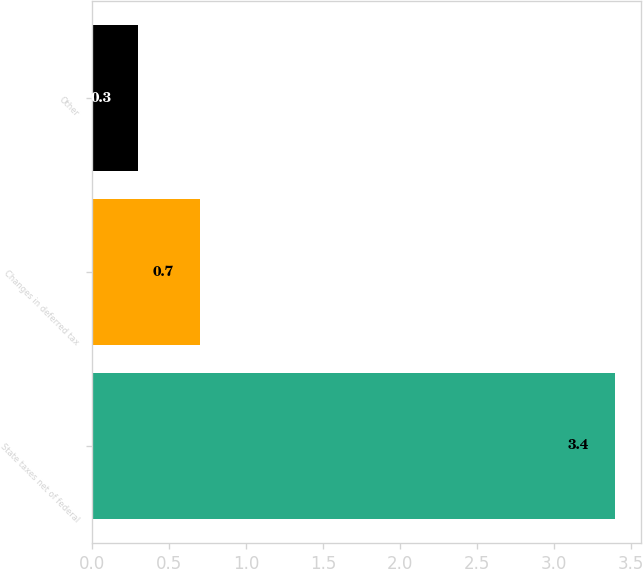Convert chart to OTSL. <chart><loc_0><loc_0><loc_500><loc_500><bar_chart><fcel>State taxes net of federal<fcel>Changes in deferred tax<fcel>Other<nl><fcel>3.4<fcel>0.7<fcel>0.3<nl></chart> 